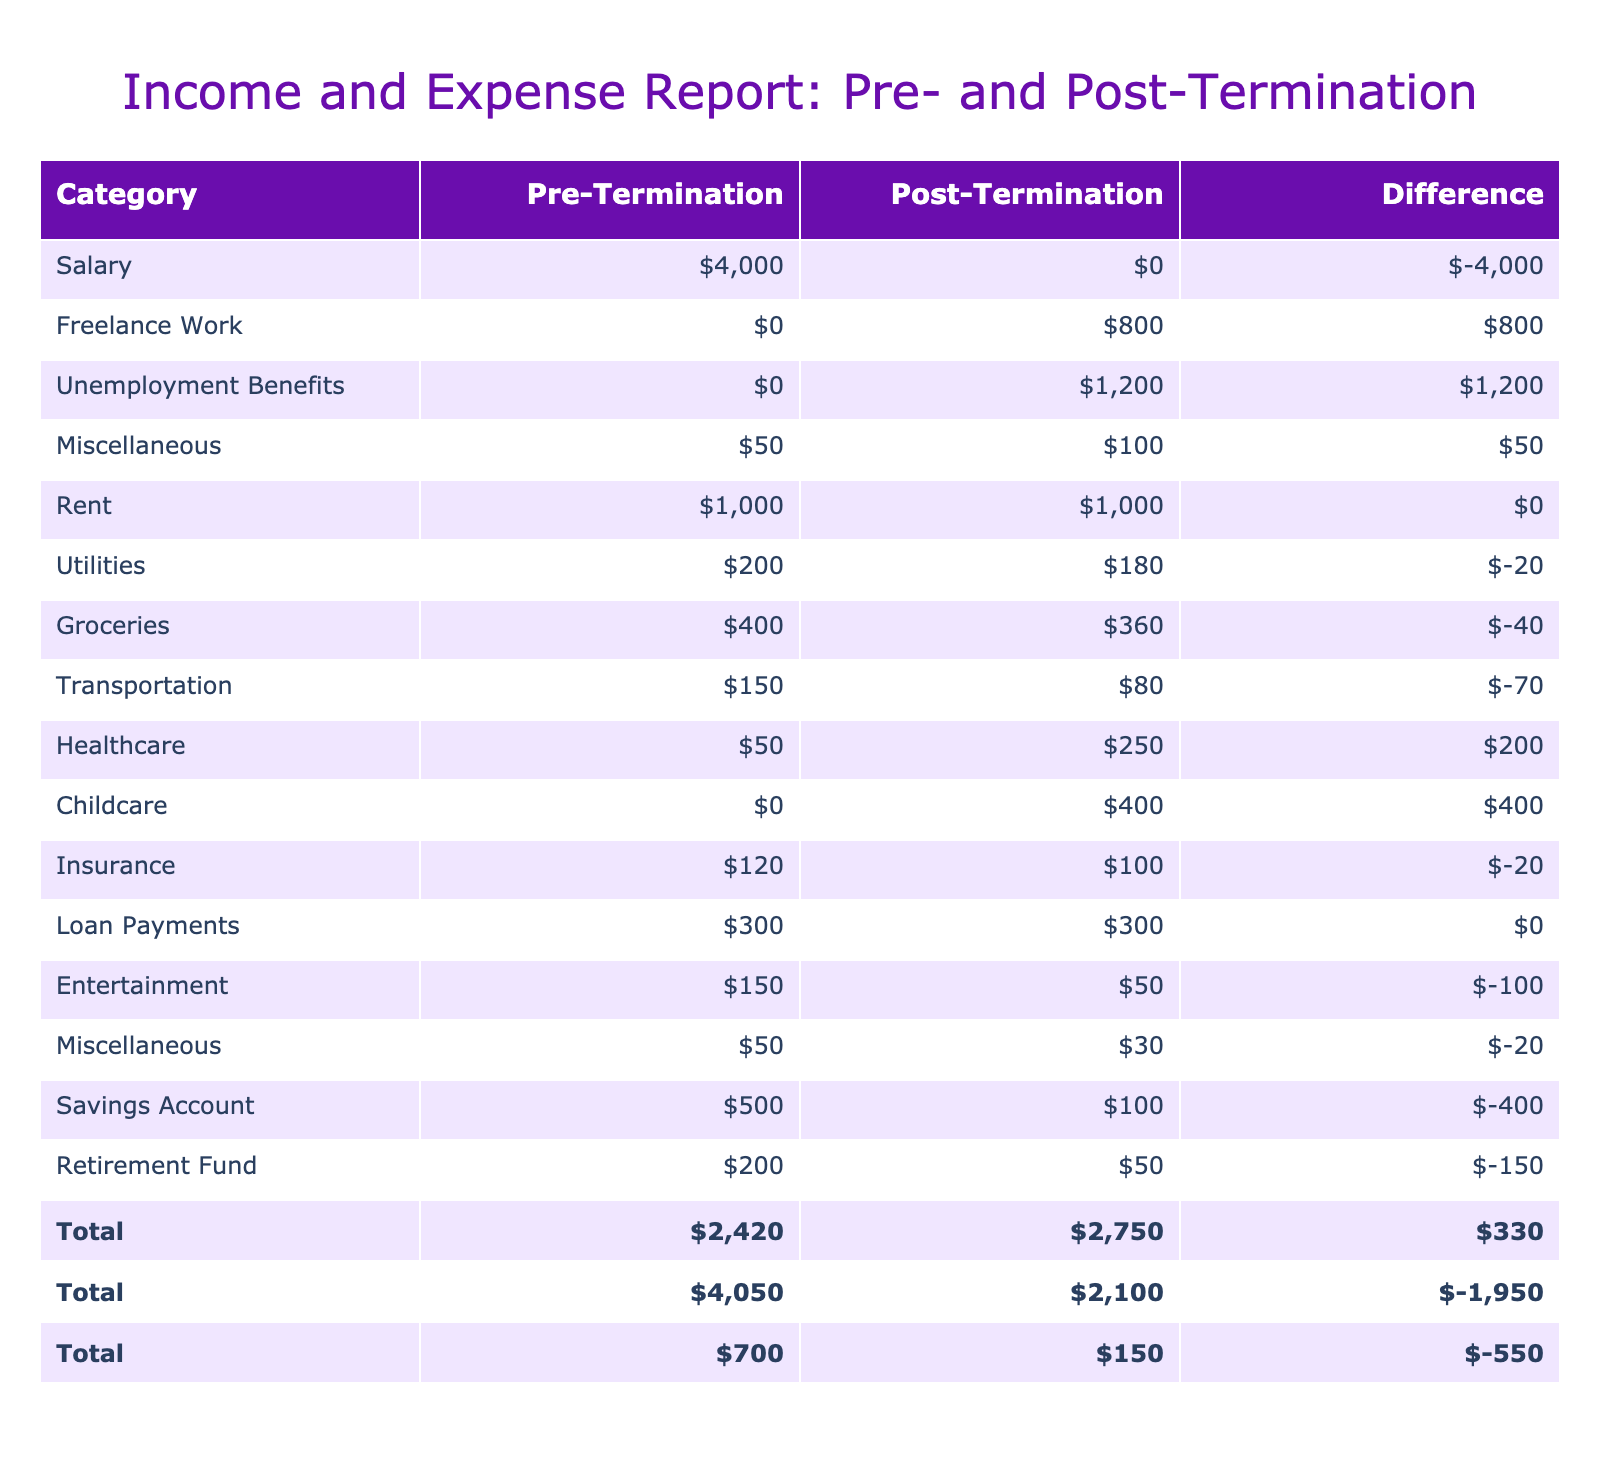What was the total salary income before termination? There was only one entry under the salary category in the pre-termination section, which is $4000. Therefore, the total salary income before termination is simply $4000.
Answer: 4000 How much did the individual earn from freelance work after termination? The table shows that the individual earned $800 from freelance work in the post-termination section.
Answer: 800 What is the difference in total monthly income before and after termination? To find this, we first sum the income categories. Total pre-termination income is $4000 (salary) + $50 (miscellaneous) = $4050. Total post-termination income is $800 (freelance) + $1200 (unemployment) + $100 (miscellaneous) = $2100. The difference is $2100 - $4050 = -$2400.
Answer: -2400 Is the increase in healthcare expenses after the termination higher than the increase in childcare expenses? Pre-termination healthcare expense was $50, and post-termination it is $250, giving an increase of $200. Pre-termination childcare expenses were $0 and post-termination are $400, giving an increase of $400. Since $200 is not greater than $400, the statement is false.
Answer: No What are the total expenses in the pre-termination period? By adding all the expenses in the pre-termination column: Rent $1000 + Utilities $200 + Groceries $400 + Transportation $150 + Healthcare $50 + Childcare $0 + Insurance $120 + Loan Payments $300 + Entertainment $150 + Miscellaneous $50 = $2500. Thus, total expenses in the pre-termination period are $2500.
Answer: 2500 What was the total reduction in the savings account after termination? The pre-termination savings amount was $500 and post-termination it is $100. The reduction is calculated as $500 - $100 = $400.
Answer: 400 Did the individual's total entertainment expenses decrease after termination? Pre-termination entertainment expenses were $150, and post-termination expenses dropped to $50. Since $50 is less than $150, the total for entertainment expenses has indeed decreased after termination, so the answer is yes.
Answer: Yes What is the overall difference between total expenses before and after termination? Total pre-termination expenses were $2500 and total post-termination expenses were $2260. The difference is calculated as $2260 - $2500 = -$240. Thus, total expenses decreased by $240.
Answer: -240 